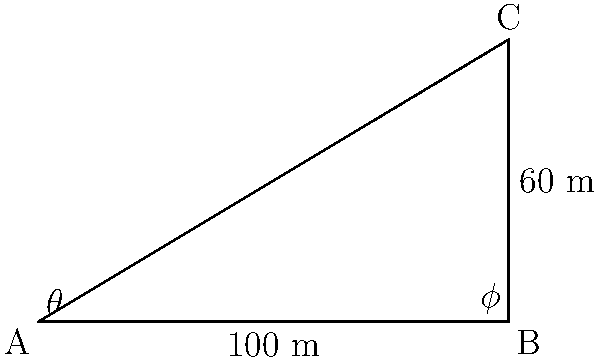As a radio host discussing urban development in Pasay City, you're explaining the concept of angle of elevation using a nearby skyscraper. From point A, the angle of elevation to the top of the skyscraper (point C) is $\theta$. You then move 100 meters closer to the base of the skyscraper to point B, where the angle of elevation is now $\phi$. If the difference between these two angles is $15^\circ$ and the height of the skyscraper is 60 meters, what is the value of $\theta$? Let's approach this step-by-step:

1) In right triangle ABC, we know:
   - The height of the skyscraper (BC) is 60 meters
   - The distance between observation points (AB) is 100 meters
   - The difference between angles $\phi$ and $\theta$ is $15^\circ$

2) We can use the tangent function for both triangles:
   $\tan \theta = \frac{60}{AC}$ and $\tan \phi = \frac{60}{BC} = \frac{60}{AC-100}$

3) We know that $\phi = \theta + 15^\circ$, so:
   $\tan (\theta + 15^\circ) = \frac{60}{AC-100}$

4) Using the tangent addition formula:
   $\frac{\tan \theta + \tan 15^\circ}{1 - \tan \theta \tan 15^\circ} = \frac{60}{AC-100}$

5) Substituting $\tan \theta = \frac{60}{AC}$ into this equation:
   $\frac{\frac{60}{AC} + \tan 15^\circ}{1 - \frac{60}{AC} \tan 15^\circ} = \frac{60}{AC-100}$

6) This gives us an equation with one unknown (AC). Solving it:
   $AC \approx 134.16$ meters

7) Now we can find $\theta$:
   $\theta = \arctan (\frac{60}{134.16}) \approx 24.1^\circ$
Answer: $24.1^\circ$ 